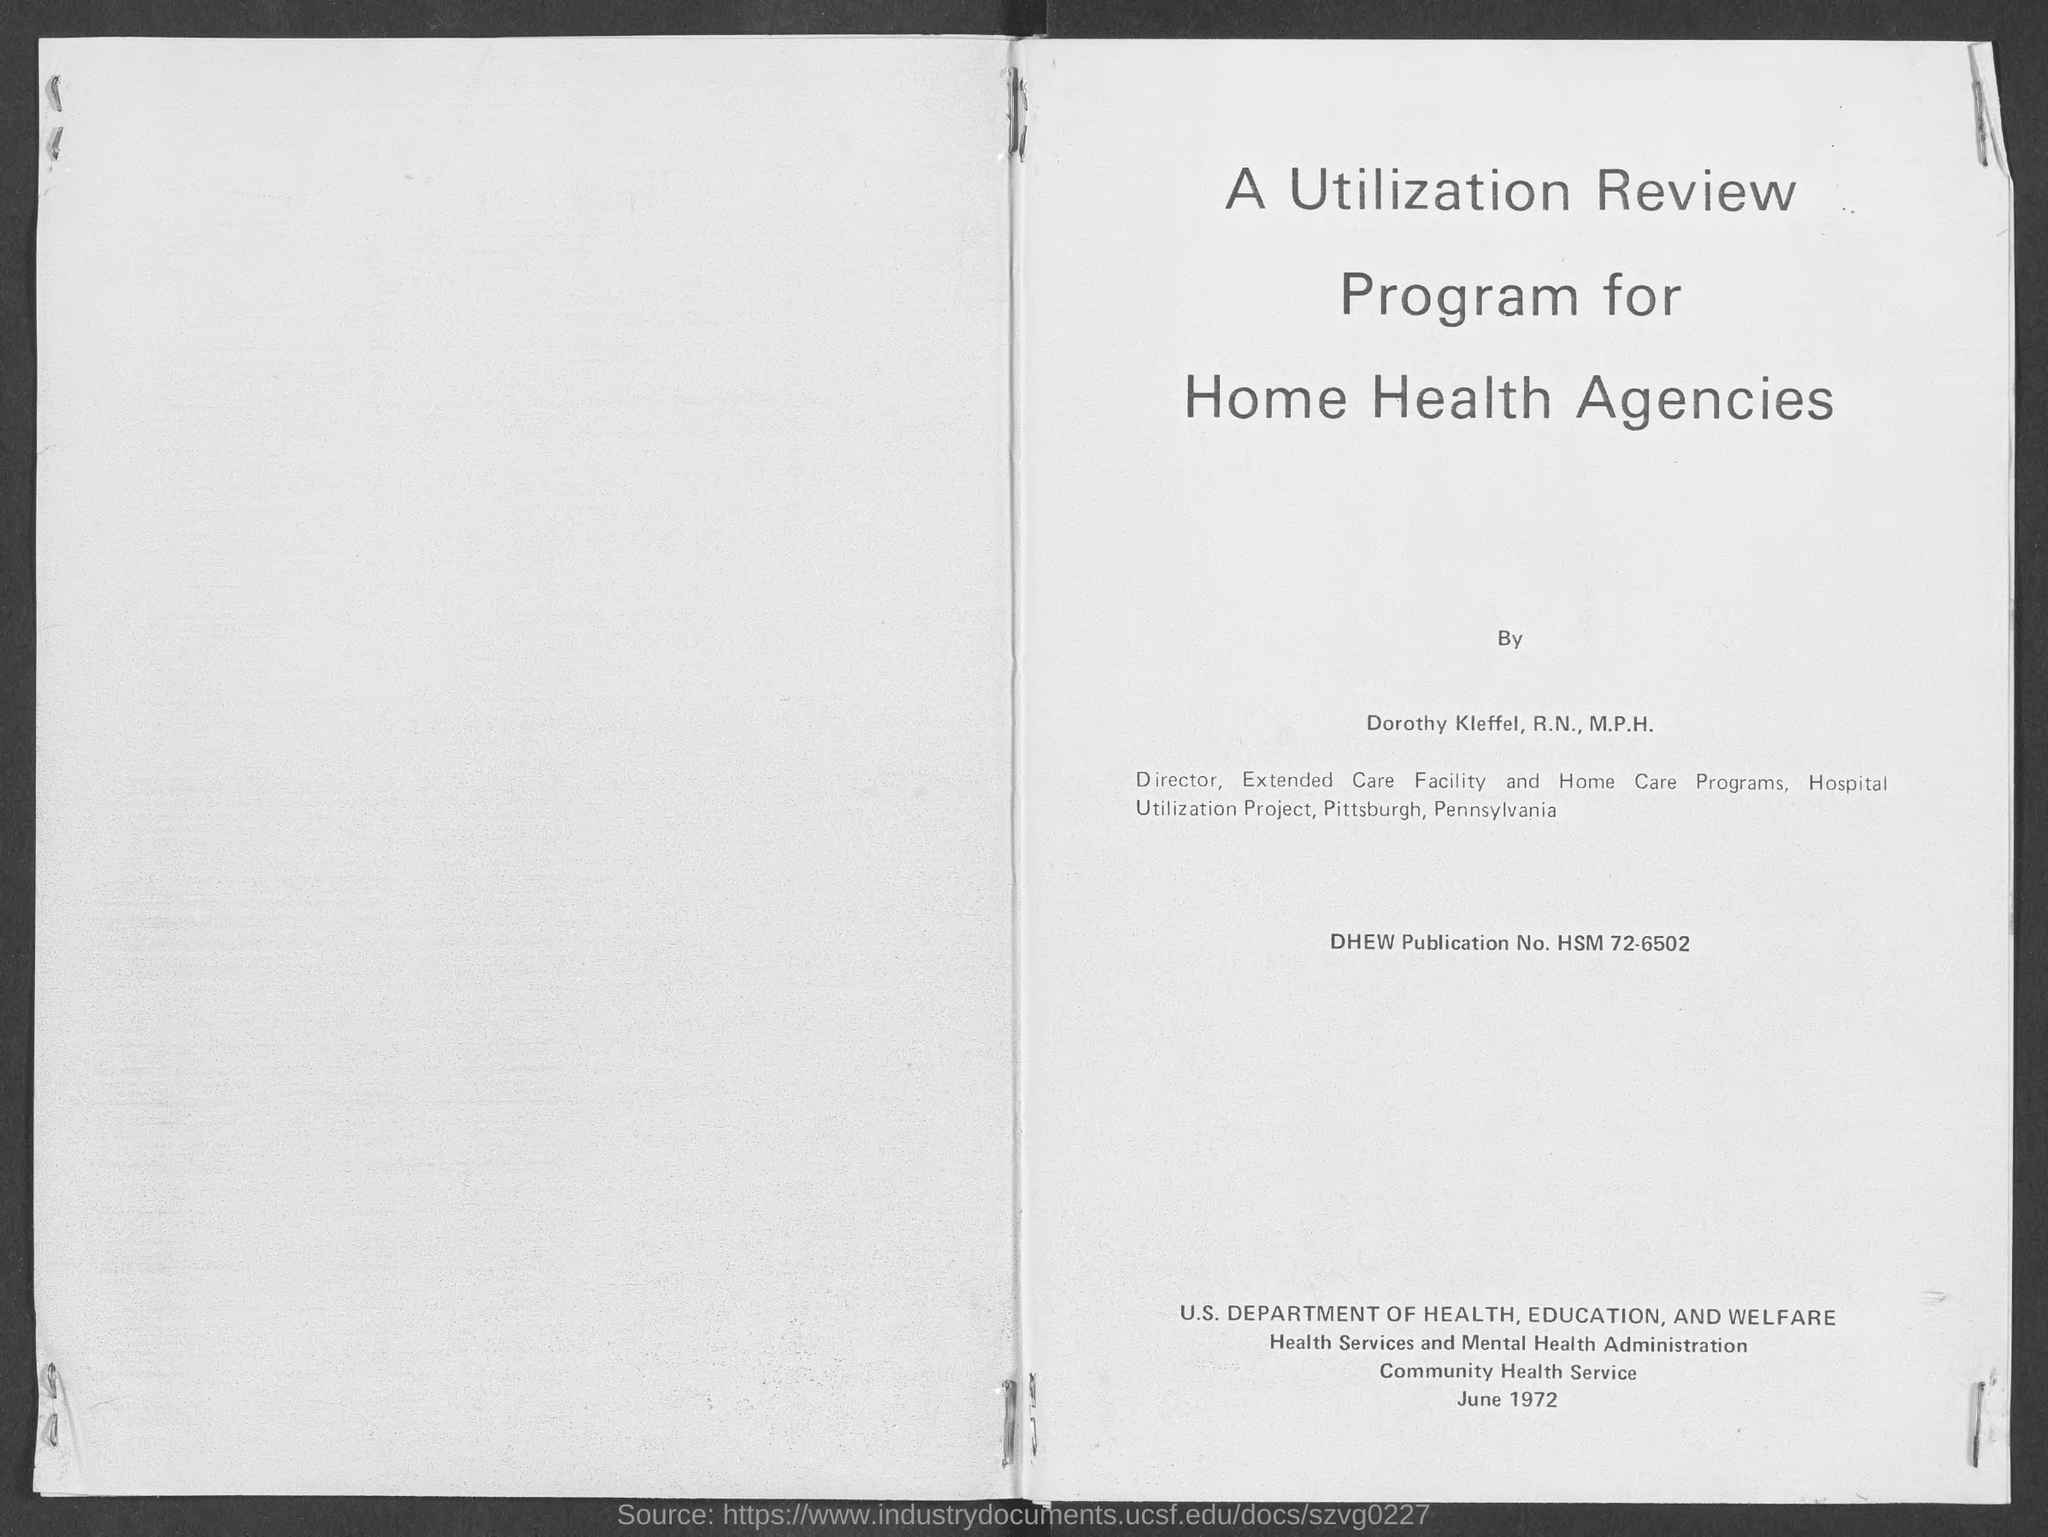List a handful of essential elements in this visual. The publication number provided is "hsm 72-6502" and the phrase following it is "What is the DHEW Publication No.?". 